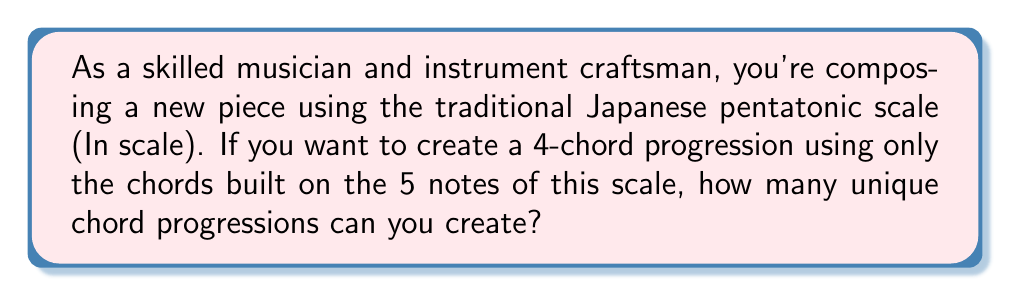Solve this math problem. Let's approach this step-by-step:

1) The Japanese pentatonic scale (In scale) consists of 5 notes.

2) We need to choose 4 chords from these 5 possible chords, and the order matters (since it's a progression).

3) This scenario is a perfect example of permutation with repetition allowed. We can use the same chord more than once in our progression.

4) The formula for permutation with repetition is:

   $$n^r$$

   Where $n$ is the number of options we have for each choice, and $r$ is the number of choices we're making.

5) In this case:
   - $n = 5$ (we have 5 chords to choose from)
   - $r = 4$ (we're creating a 4-chord progression)

6) Plugging these values into our formula:

   $$5^4 = 5 \times 5 \times 5 \times 5 = 625$$

Therefore, there are 625 possible unique 4-chord progressions using the chords from the Japanese pentatonic scale.
Answer: 625 